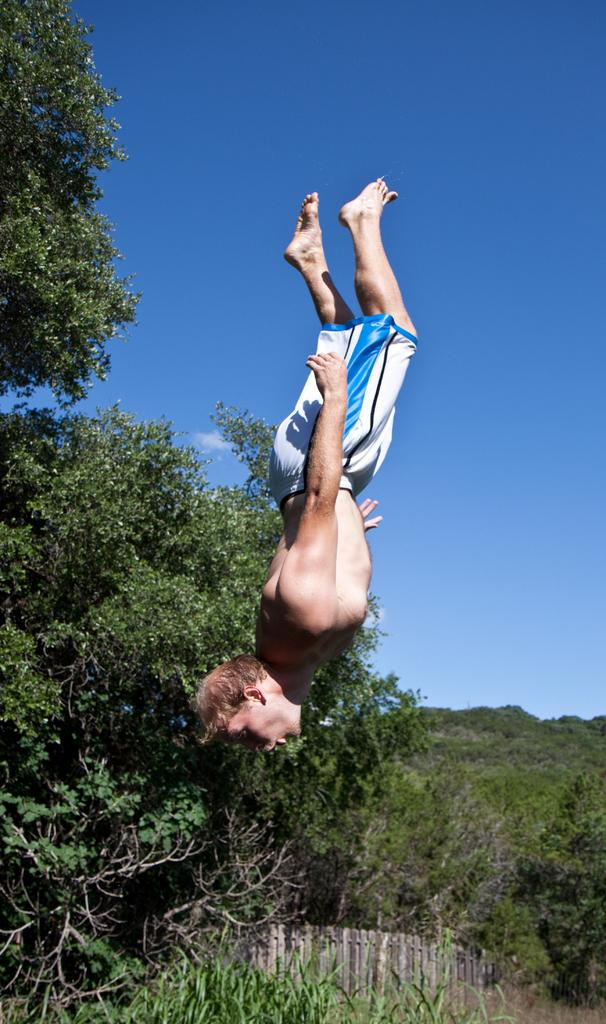What is happening with the person in the image? There is a person in the air in the image. What can be seen in the background of the image? There are trees and a fence wall in the background of the image. What type of hat is the person wearing in the image? There is no hat visible in the image. 